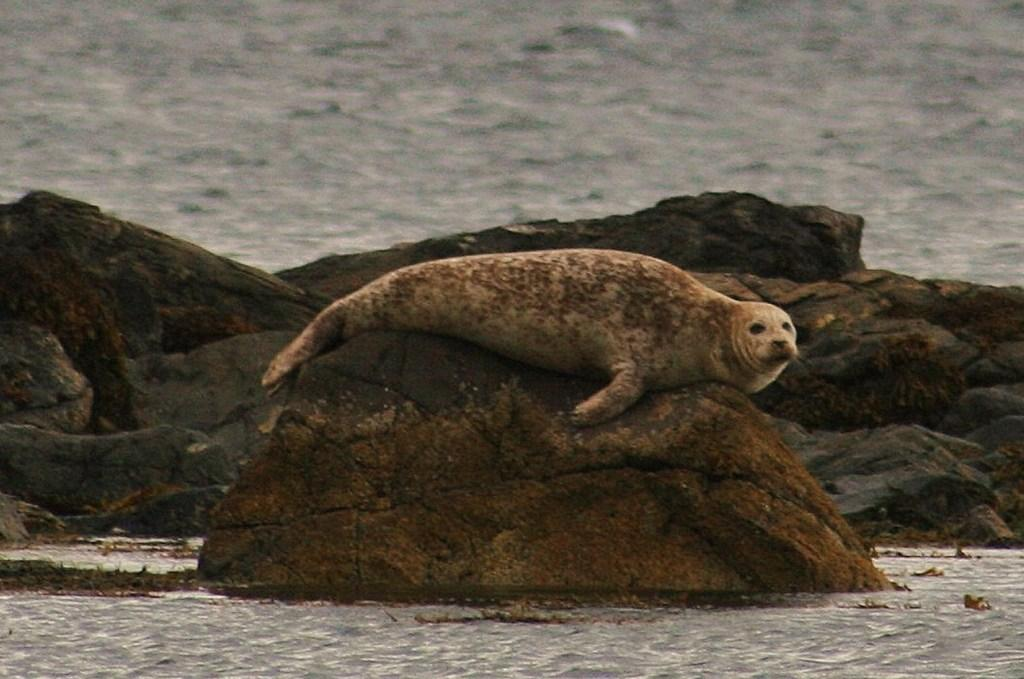What animal can be seen in the image? There is a seal on the rocks in the image. What type of environment is depicted in the image? The image shows a coastal environment, with rocks and water visible. Can you describe the water in the image? There is water visible in the background and at the bottom of the image. What type of zipper can be seen on the seal's back in the image? There is no zipper present on the seal's back in the image. How many bubbles are floating around the seal in the image? There are no bubbles visible in the image. 